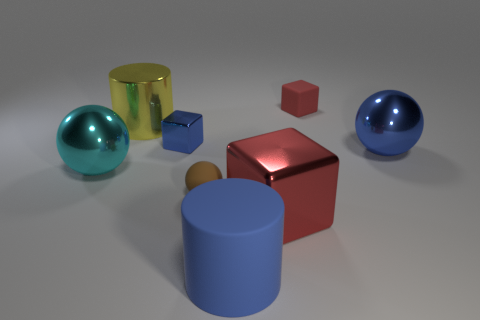Add 3 blue shiny cubes. How many blue shiny cubes exist? 4 Add 2 shiny objects. How many objects exist? 10 Subtract all blue balls. How many balls are left? 2 Subtract all tiny brown spheres. How many spheres are left? 2 Subtract 1 blue cubes. How many objects are left? 7 Subtract all cubes. How many objects are left? 5 Subtract 2 cubes. How many cubes are left? 1 Subtract all purple cylinders. Subtract all blue blocks. How many cylinders are left? 2 Subtract all purple cubes. How many brown spheres are left? 1 Subtract all big cyan things. Subtract all blue cylinders. How many objects are left? 6 